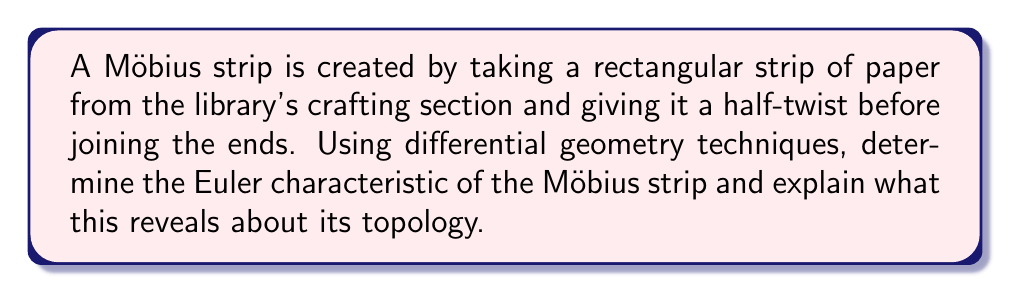Solve this math problem. To analyze the topology of a Möbius strip using differential geometry techniques, we'll follow these steps:

1. Parameterization:
Let's parameterize the Möbius strip as:
$$r(u,v) = ((R + v\cos(\frac{u}{2}))\cos(u), (R + v\cos(\frac{u}{2}))\sin(u), v\sin(\frac{u}{2}))$$
where $0 \leq u < 2\pi$ and $-w \leq v \leq w$, with $R$ being the radius of the central circle and $w$ being the width of the strip.

2. Fundamental forms:
Calculate the first fundamental form coefficients:
$$E = \left\langle \frac{\partial r}{\partial u}, \frac{\partial r}{\partial u} \right\rangle$$
$$F = \left\langle \frac{\partial r}{\partial u}, \frac{\partial r}{\partial v} \right\rangle$$
$$G = \left\langle \frac{\partial r}{\partial v}, \frac{\partial r}{\partial v} \right\rangle$$

3. Gaussian curvature:
Compute the Gaussian curvature $K$ using:
$$K = \frac{LN - M^2}{EG - F^2}$$
where $L$, $M$, and $N$ are coefficients of the second fundamental form.

4. Gauss-Bonnet theorem:
Apply the Gauss-Bonnet theorem:
$$\int\int_M K dA + \int_{\partial M} k_g ds = 2\pi\chi(M)$$
where $\chi(M)$ is the Euler characteristic, $k_g$ is the geodesic curvature, and $\partial M$ is the boundary of the surface.

5. Euler characteristic:
For a Möbius strip, the integral of the Gaussian curvature over the surface is zero, and the boundary consists of a single closed curve. The geodesic curvature integrates to $\pi$ (half of what it would for a cylinder). Thus:
$$0 + \pi = 2\pi\chi(M)$$
$$\chi(M) = \frac{1}{2}$$

6. Topological interpretation:
The Euler characteristic of $\frac{1}{2}$ indicates that the Möbius strip is a non-orientable surface with one boundary component. It has the same topology as a projective plane with a disk removed.
Answer: $\chi(\text{Möbius strip}) = \frac{1}{2}$ 